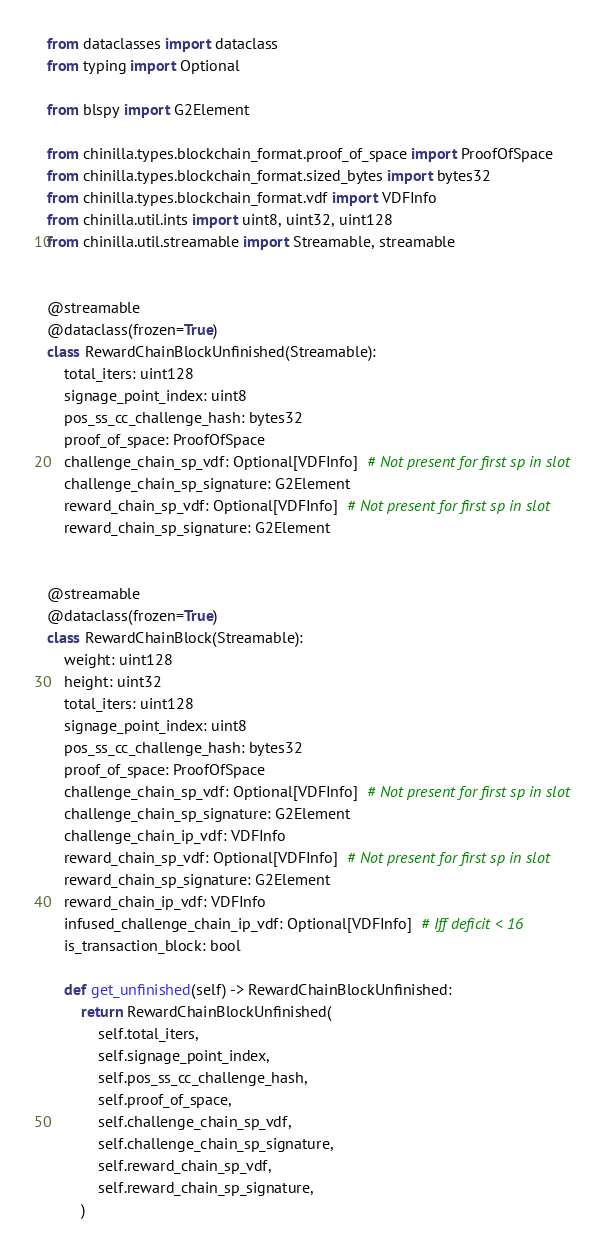Convert code to text. <code><loc_0><loc_0><loc_500><loc_500><_Python_>from dataclasses import dataclass
from typing import Optional

from blspy import G2Element

from chinilla.types.blockchain_format.proof_of_space import ProofOfSpace
from chinilla.types.blockchain_format.sized_bytes import bytes32
from chinilla.types.blockchain_format.vdf import VDFInfo
from chinilla.util.ints import uint8, uint32, uint128
from chinilla.util.streamable import Streamable, streamable


@streamable
@dataclass(frozen=True)
class RewardChainBlockUnfinished(Streamable):
    total_iters: uint128
    signage_point_index: uint8
    pos_ss_cc_challenge_hash: bytes32
    proof_of_space: ProofOfSpace
    challenge_chain_sp_vdf: Optional[VDFInfo]  # Not present for first sp in slot
    challenge_chain_sp_signature: G2Element
    reward_chain_sp_vdf: Optional[VDFInfo]  # Not present for first sp in slot
    reward_chain_sp_signature: G2Element


@streamable
@dataclass(frozen=True)
class RewardChainBlock(Streamable):
    weight: uint128
    height: uint32
    total_iters: uint128
    signage_point_index: uint8
    pos_ss_cc_challenge_hash: bytes32
    proof_of_space: ProofOfSpace
    challenge_chain_sp_vdf: Optional[VDFInfo]  # Not present for first sp in slot
    challenge_chain_sp_signature: G2Element
    challenge_chain_ip_vdf: VDFInfo
    reward_chain_sp_vdf: Optional[VDFInfo]  # Not present for first sp in slot
    reward_chain_sp_signature: G2Element
    reward_chain_ip_vdf: VDFInfo
    infused_challenge_chain_ip_vdf: Optional[VDFInfo]  # Iff deficit < 16
    is_transaction_block: bool

    def get_unfinished(self) -> RewardChainBlockUnfinished:
        return RewardChainBlockUnfinished(
            self.total_iters,
            self.signage_point_index,
            self.pos_ss_cc_challenge_hash,
            self.proof_of_space,
            self.challenge_chain_sp_vdf,
            self.challenge_chain_sp_signature,
            self.reward_chain_sp_vdf,
            self.reward_chain_sp_signature,
        )
</code> 